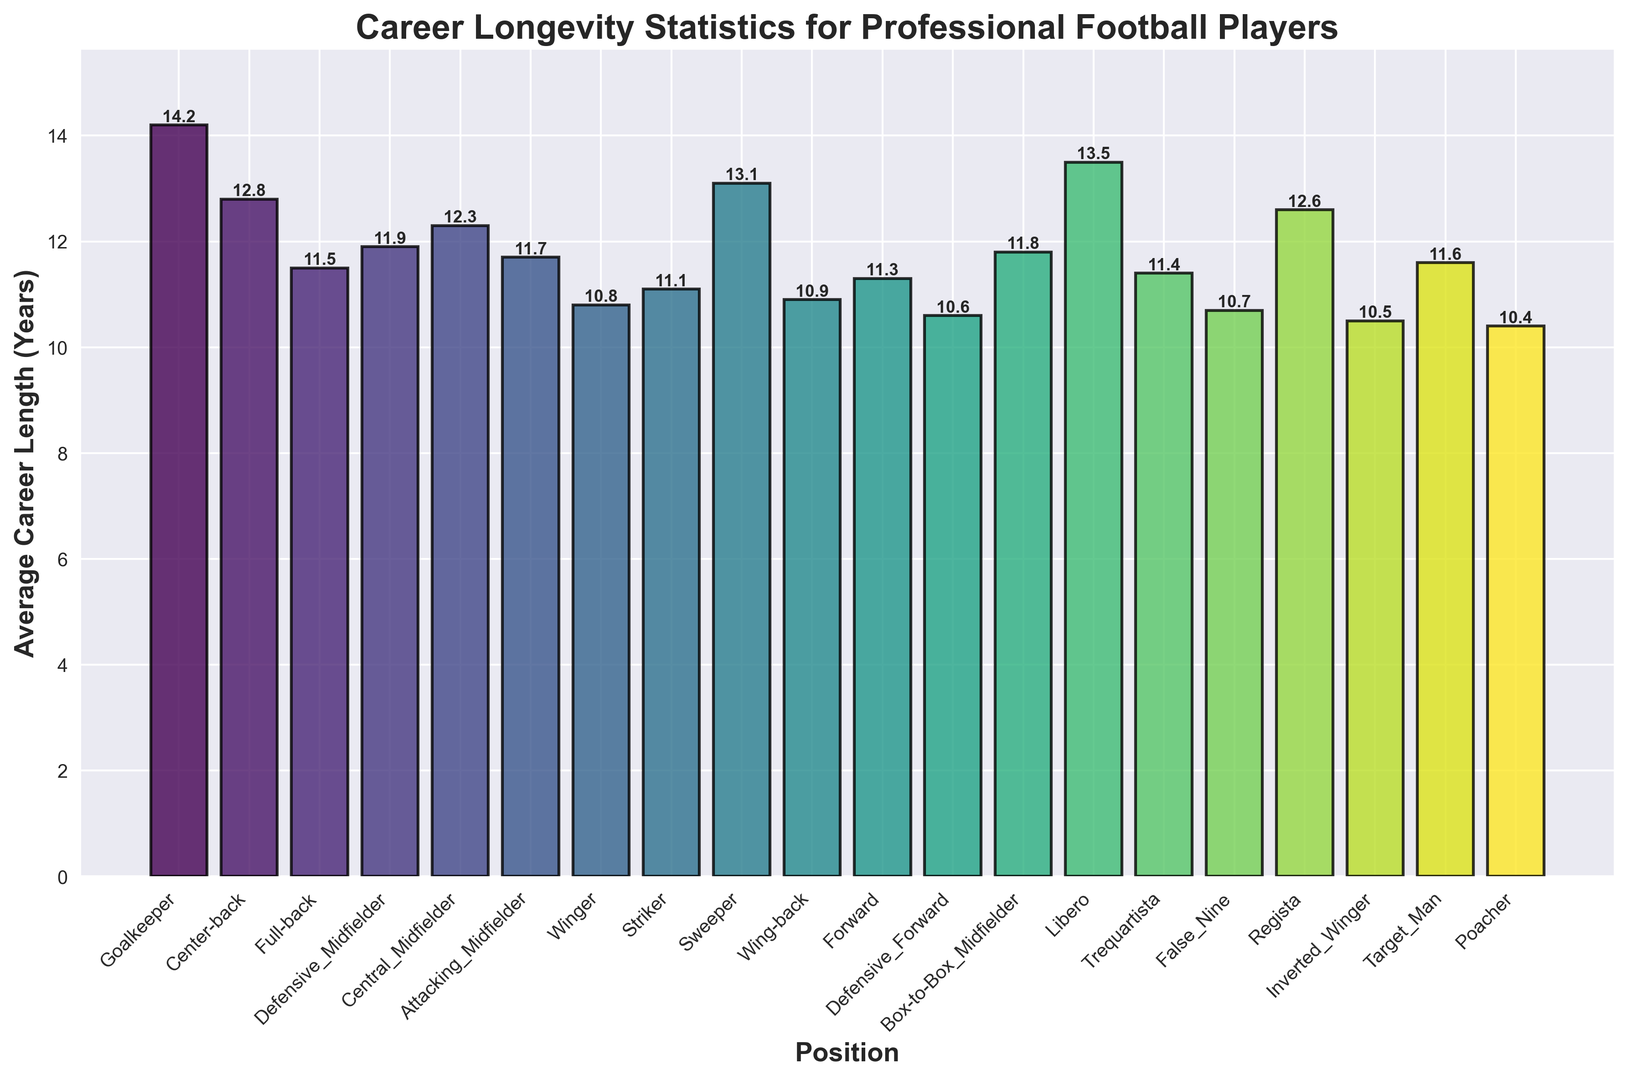Which position has the longest average career length? By examining the heights of the bars, the position with the tallest bar represents the longest average career length. The Goalkeeper has the longest career length at 14.2 years.
Answer: Goalkeeper Which position has the shortest average career length? By looking at the bars and identifying the shortest one, we find that Poacher has the shortest average career length at 10.4 years.
Answer: Poacher Compare the average career lengths of Center-back and Winger. Which is longer? By comparing the heights of the bars for Center-back and Winger, we see that Center-back has an average career length of 12.8 years, which is longer than Winger’s 10.8 years.
Answer: Center-back What is the difference in average career length between a Goalkeeper and a Poacher? Subtract the average career length of the Poacher (10.4 years) from that of the Goalkeeper (14.2 years): 14.2 - 10.4 = 3.8 years.
Answer: 3.8 years Which position shows a similar average career length to a Forward? By comparing the bar heights, Central Midfielder (12.3 years), Defensive Midfielder (11.9 years), and Attacking Midfielder (11.7 years) have average career lengths close to Forward’s 11.3 years.
Answer: Attacking Midfielder By how many years does a Sweeper's career length differ from a Box-to-Box Midfielder? Subtract the career length of Box-to-Box Midfielder (11.8 years) from Sweeper (13.1 years): 13.1 - 11.8 = 1.3 years.
Answer: 1.3 years On average, which position experiences a shorter career length: False Nine or Target Man? By comparing the heights of the bars, False Nine has an average career length of 10.7 years, which is similar but slightly shorter than Target Man at 11.6 years.
Answer: False Nine Which position has an average career length closest to 11 years? By inspecting the bars, several positions are around 11 years, but Full-back has an average career length of 11.5 years which is closest to 11 years.
Answer: Full-back Calculate the average career length of all midfielder positions combined. Add the lengths for Defensive Midfielder (11.9 years), Central Midfielder (12.3 years), Attacking Midfielder (11.7 years), Box-to-Box Midfielder (11.8 years), Trequartista (11.4 years), Regista (12.6 years), and divide by 6: (11.9 + 12.3 + 11.7 + 11.8 + 11.4 + 12.6)/6 = 12.0 years.
Answer: 12.0 years 